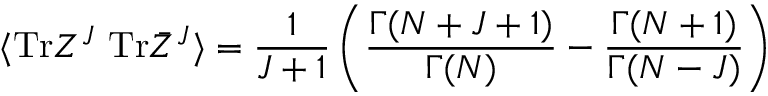Convert formula to latex. <formula><loc_0><loc_0><loc_500><loc_500>\langle T r Z ^ { J } T r \bar { Z } ^ { J } \rangle = \frac { 1 } { J + 1 } \left ( \frac { \Gamma ( N + J + 1 ) } { \Gamma ( N ) } - \frac { \Gamma ( N + 1 ) } { \Gamma ( N - J ) } \right )</formula> 